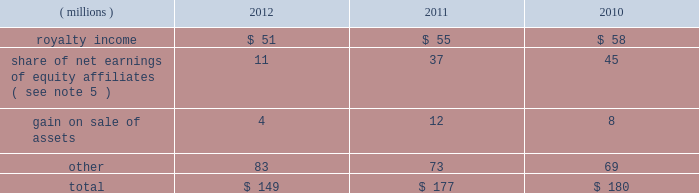68 2012 ppg annual report and form 10-k december 31 , 2012 , 2011 and 2010 was $ ( 30 ) million , $ 98 million and $ 65 million , respectively .
The cumulative tax benefit related to the adjustment for pension and other postretirement benefits at december 31 , 2012 and 2011 was approximately $ 960 million and $ 990 million , respectively .
There was no tax ( cost ) benefit related to the change in the unrealized gain ( loss ) on marketable securities for the year ended december 31 , 2012 .
The tax ( cost ) benefit related to the change in the unrealized gain ( loss ) on marketable securities for the years ended december 31 , 2011 and 2010 was $ ( 0.2 ) million and $ 0.6 million , respectively .
The tax benefit related to the change in the unrealized gain ( loss ) on derivatives for the years ended december 31 , 2012 , 2011 and 2010 was $ 4 million , $ 19 million and $ 1 million , respectively .
18 .
Employee savings plan ppg 2019s employee savings plan ( 201csavings plan 201d ) covers substantially all u.s .
Employees .
The company makes matching contributions to the savings plan , at management's discretion , based upon participants 2019 savings , subject to certain limitations .
For most participants not covered by a collective bargaining agreement , company-matching contributions are established each year at the discretion of the company and are applied to participant savings up to a maximum of 6% ( 6 % ) of eligible participant compensation .
For those participants whose employment is covered by a collective bargaining agreement , the level of company-matching contribution , if any , is determined by the relevant collective bargaining agreement .
The company-matching contribution was suspended from march 2009 through june 2010 as a cost savings measure in recognition of the adverse impact of the global recession .
Effective july 1 , 2010 , the company match was reinstated at 50% ( 50 % ) on the first 6% ( 6 % ) of compensation contributed for most employees eligible for the company-matching contribution feature .
This included the union represented employees in accordance with their collective bargaining agreements .
On january 1 , 2011 , the company match was increased to 75% ( 75 % ) on the first 6% ( 6 % ) of compensation contributed by these eligible employees and this level was maintained throughout 2012 .
Compensation expense and cash contributions related to the company match of participant contributions to the savings plan for 2012 , 2011 and 2010 totaled $ 28 million , $ 26 million and $ 9 million , respectively .
A portion of the savings plan qualifies under the internal revenue code as an employee stock ownership plan .
As a result , the dividends on ppg shares held by that portion of the savings plan totaling $ 18 million , $ 20 million and $ 24 million for 2012 , 2011 and 2010 , respectively , were tax deductible to the company for u.s .
Federal tax purposes .
19 .
Other earnings .
20 .
Stock-based compensation the company 2019s stock-based compensation includes stock options , restricted stock units ( 201crsus 201d ) and grants of contingent shares that are earned based on achieving targeted levels of total shareholder return .
All current grants of stock options , rsus and contingent shares are made under the ppg industries , inc .
Amended and restated omnibus incentive plan ( 201cppg amended omnibus plan 201d ) , which was amended and restated effective april 21 , 2011 .
Shares available for future grants under the ppg amended omnibus plan were 8.5 million as of december 31 , 2012 .
Total stock-based compensation cost was $ 73 million , $ 36 million and $ 52 million in 2012 , 2011 and 2010 , respectively .
Stock-based compensation expense increased year over year due to the increase in the expected payout percentage of the 2010 performance-based rsu grants and ppg's total shareholder return performance in 2012 in comparison with the standard & poors ( s&p ) 500 index , which has increased the expense related to outstanding grants of contingent shares .
The total income tax benefit recognized in the accompanying consolidated statement of income related to the stock-based compensation was $ 25 million , $ 13 million and $ 18 million in 2012 , 2011 and 2010 , respectively .
Stock options ppg has outstanding stock option awards that have been granted under two stock option plans : the ppg industries , inc .
Stock plan ( 201cppg stock plan 201d ) and the ppg amended omnibus plan .
Under the ppg amended omnibus plan and the ppg stock plan , certain employees of the company have been granted options to purchase shares of common stock at prices equal to the fair market value of the shares on the date the options were granted .
The options are generally exercisable beginning from six to 48 months after being granted and have a maximum term of 10 years .
Upon exercise of a stock option , shares of company stock are issued from treasury stock .
The ppg stock plan includes a restored option provision for options originally granted prior to january 1 , 2003 that allows an optionee to exercise options and satisfy the option cost by certifying ownership of mature shares of ppg common stock with a market value equal to the option cost .
The fair value of stock options issued to employees is measured on the date of grant and is recognized as expense over the requisite service period .
Ppg estimates the fair value of stock options using the black-scholes option pricing model .
The risk- free interest rate is determined by using the u.s .
Treasury yield table of contents .
What was the percentage change in stock-based compensation between 2011 and 2012? 
Computations: ((73 - 36) / 36)
Answer: 1.02778. 